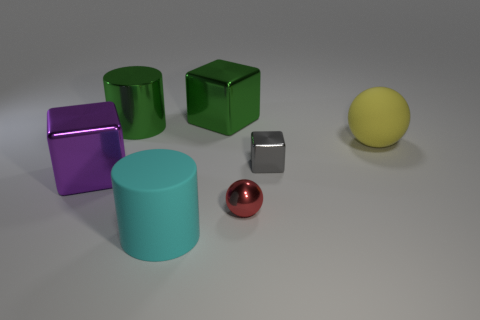Add 2 big brown matte cylinders. How many objects exist? 9 Subtract all cylinders. How many objects are left? 5 Subtract 0 blue cylinders. How many objects are left? 7 Subtract all small yellow matte objects. Subtract all large green blocks. How many objects are left? 6 Add 1 cyan objects. How many cyan objects are left? 2 Add 7 green objects. How many green objects exist? 9 